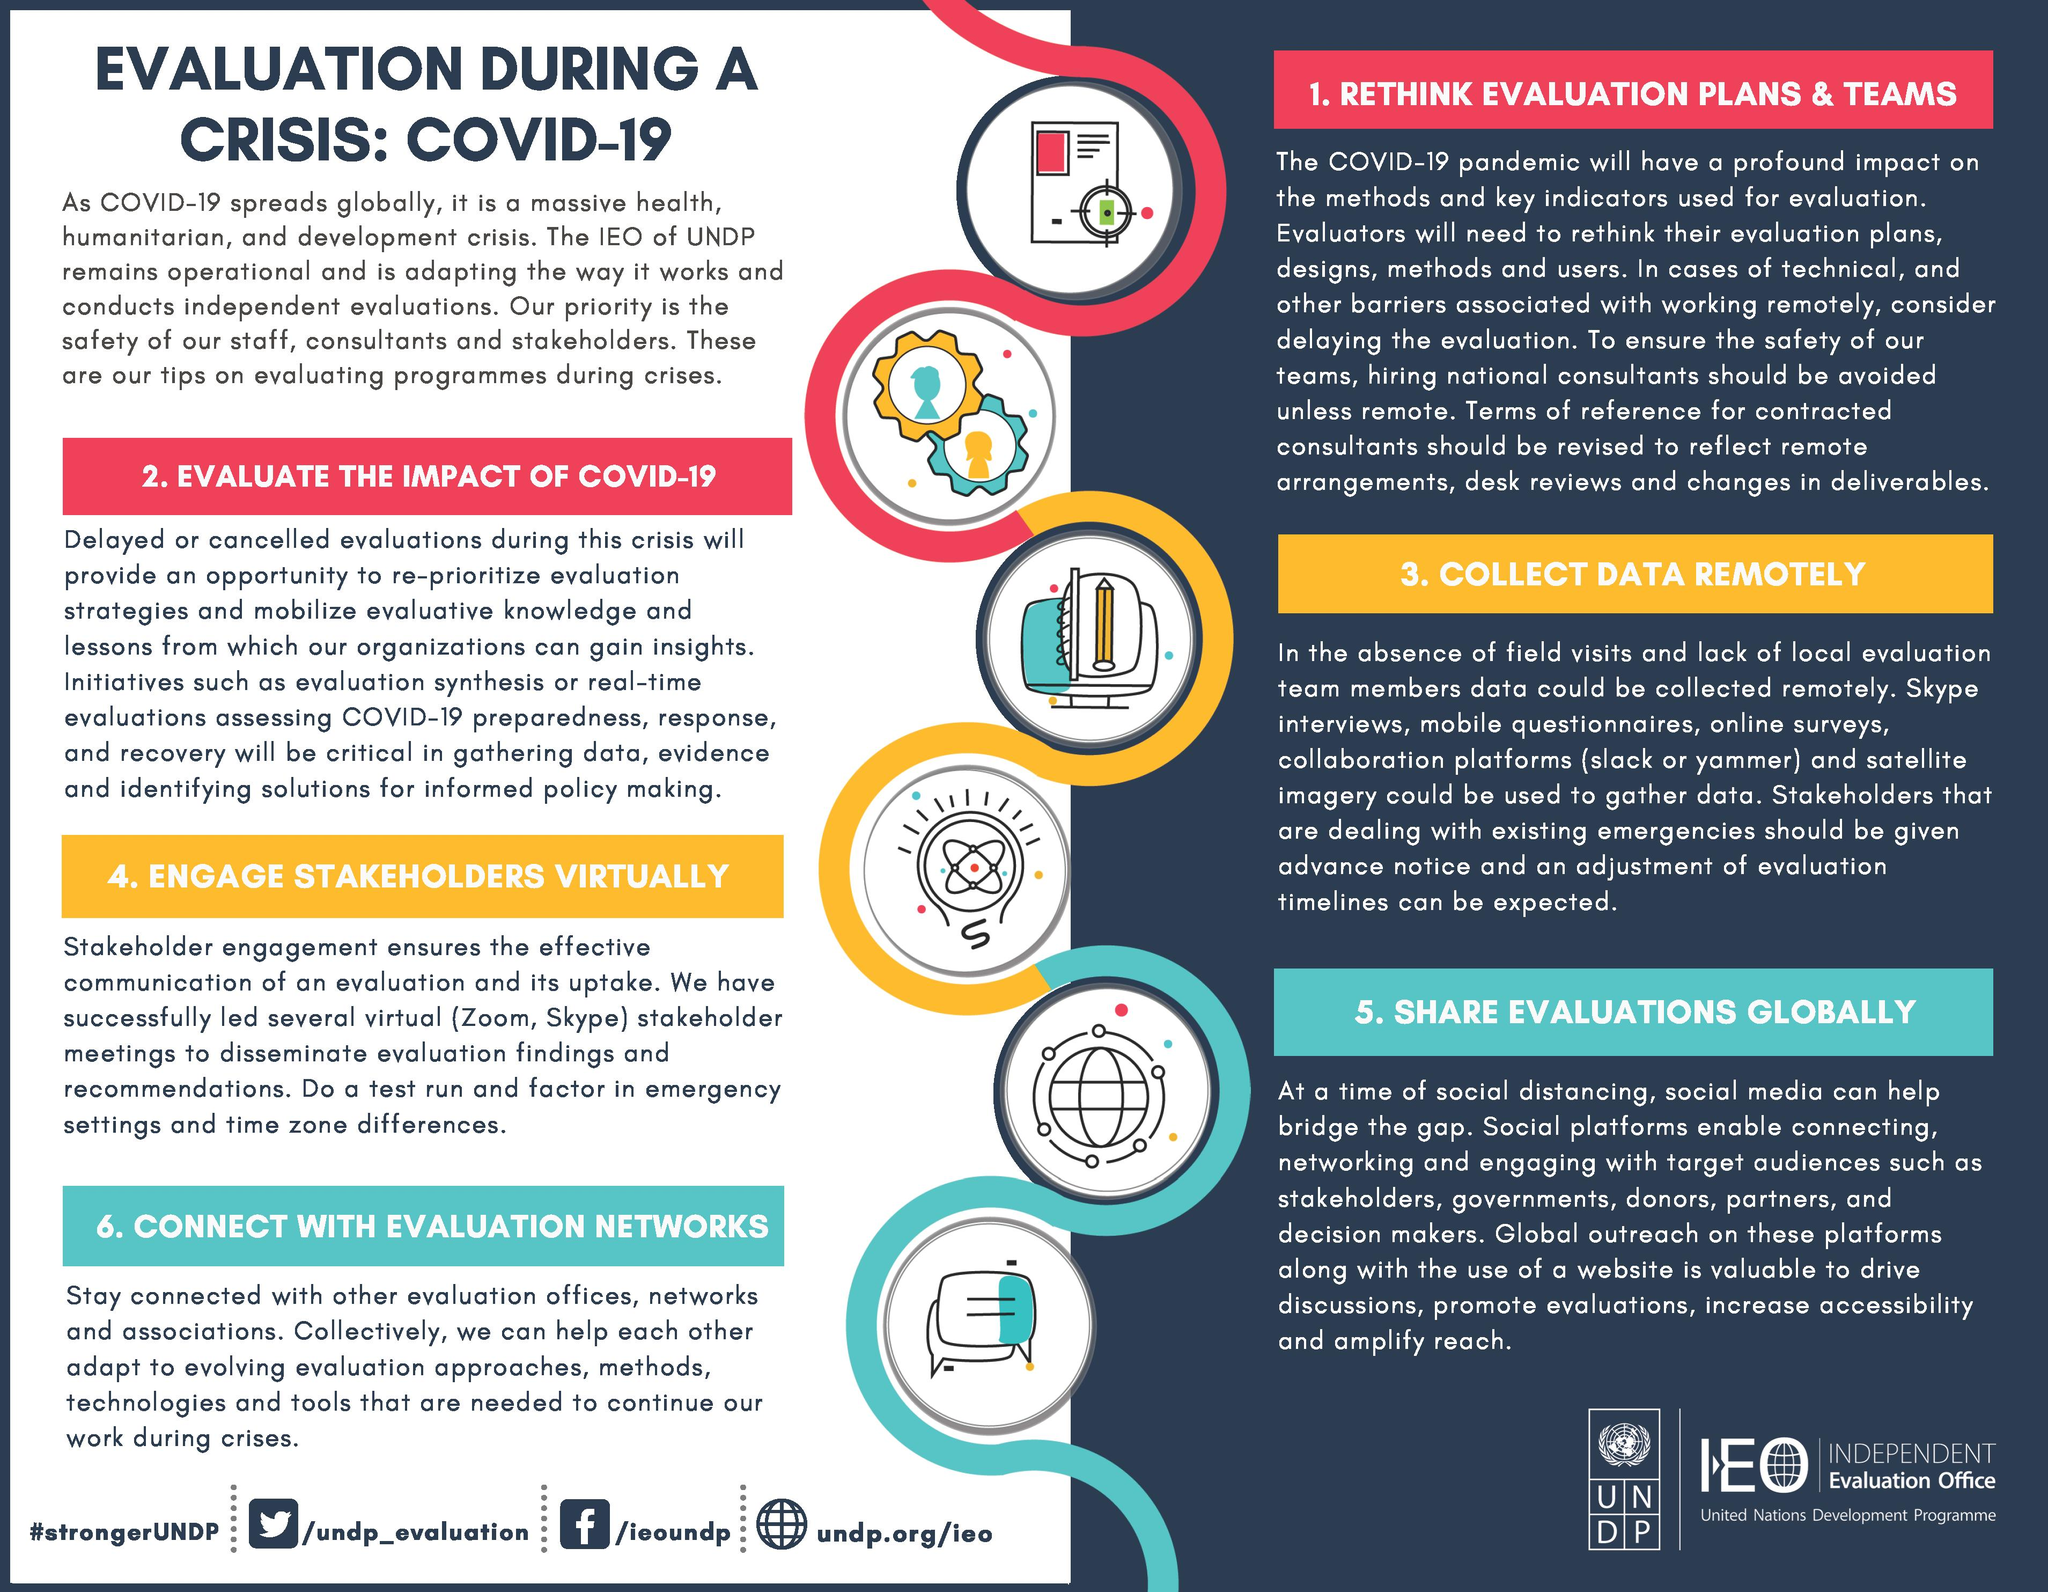Mention a couple of crucial points in this snapshot. This infographic provides six tips to aid in the evaluation process during a crisis. The second last subtopic of this infographic is 'Share evaluations globally,' which involves sharing evaluations of the product or service with a global audience. There are three tips listed in the left column of the document. The second tip given in the infographic for the evaluation of programs is to evaluate the impact of COVID-19. The topic that is provided at the bottom-right section is asking for evaluations to be shared globally. 